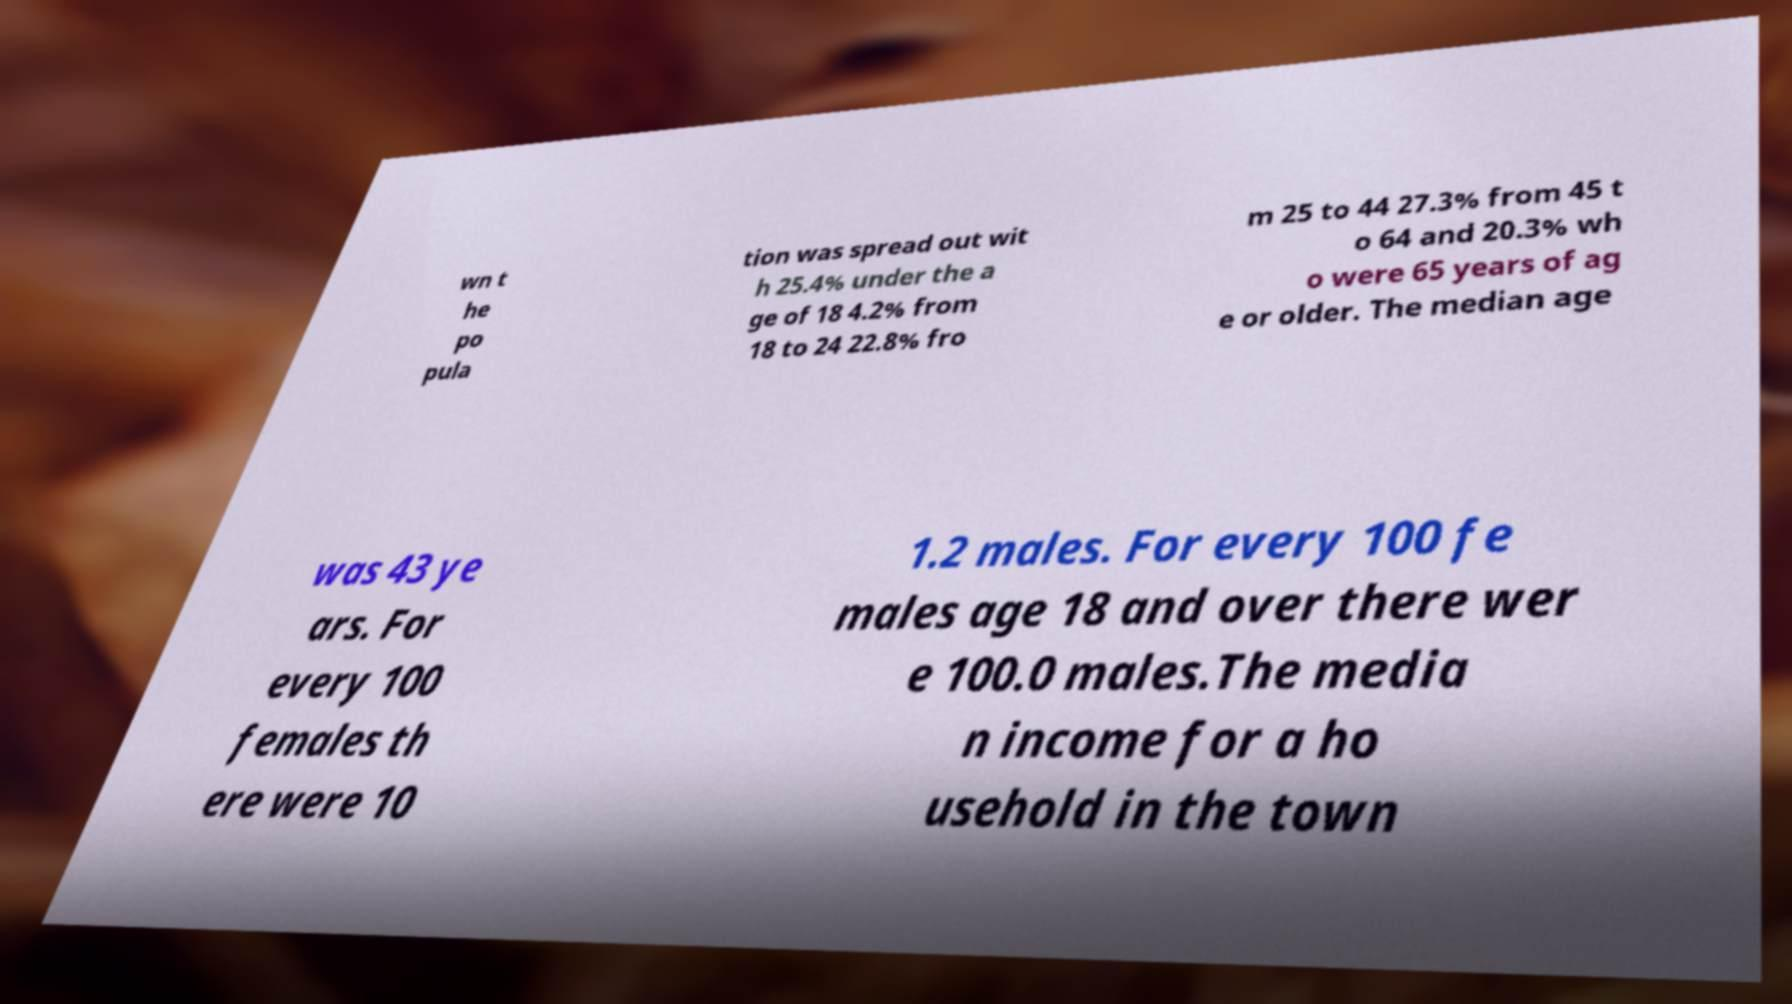Can you read and provide the text displayed in the image?This photo seems to have some interesting text. Can you extract and type it out for me? wn t he po pula tion was spread out wit h 25.4% under the a ge of 18 4.2% from 18 to 24 22.8% fro m 25 to 44 27.3% from 45 t o 64 and 20.3% wh o were 65 years of ag e or older. The median age was 43 ye ars. For every 100 females th ere were 10 1.2 males. For every 100 fe males age 18 and over there wer e 100.0 males.The media n income for a ho usehold in the town 